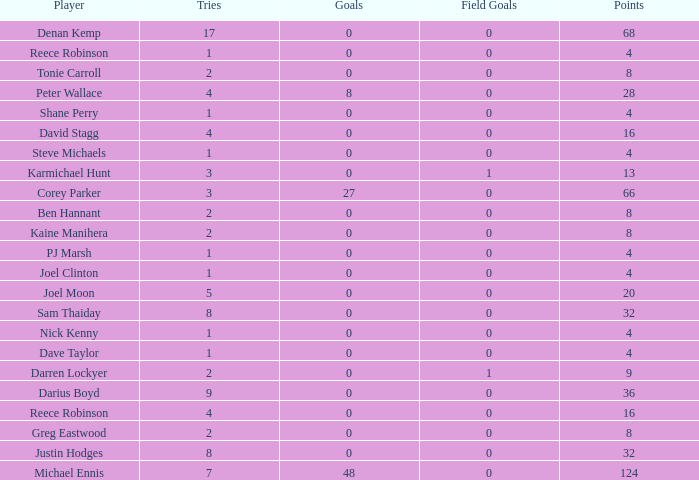What is the lowest tries the player with more than 0 goals, 28 points, and more than 0 field goals have? None. 